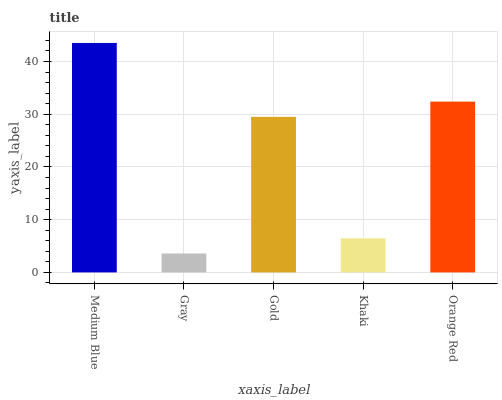Is Gray the minimum?
Answer yes or no. Yes. Is Medium Blue the maximum?
Answer yes or no. Yes. Is Gold the minimum?
Answer yes or no. No. Is Gold the maximum?
Answer yes or no. No. Is Gold greater than Gray?
Answer yes or no. Yes. Is Gray less than Gold?
Answer yes or no. Yes. Is Gray greater than Gold?
Answer yes or no. No. Is Gold less than Gray?
Answer yes or no. No. Is Gold the high median?
Answer yes or no. Yes. Is Gold the low median?
Answer yes or no. Yes. Is Medium Blue the high median?
Answer yes or no. No. Is Gray the low median?
Answer yes or no. No. 